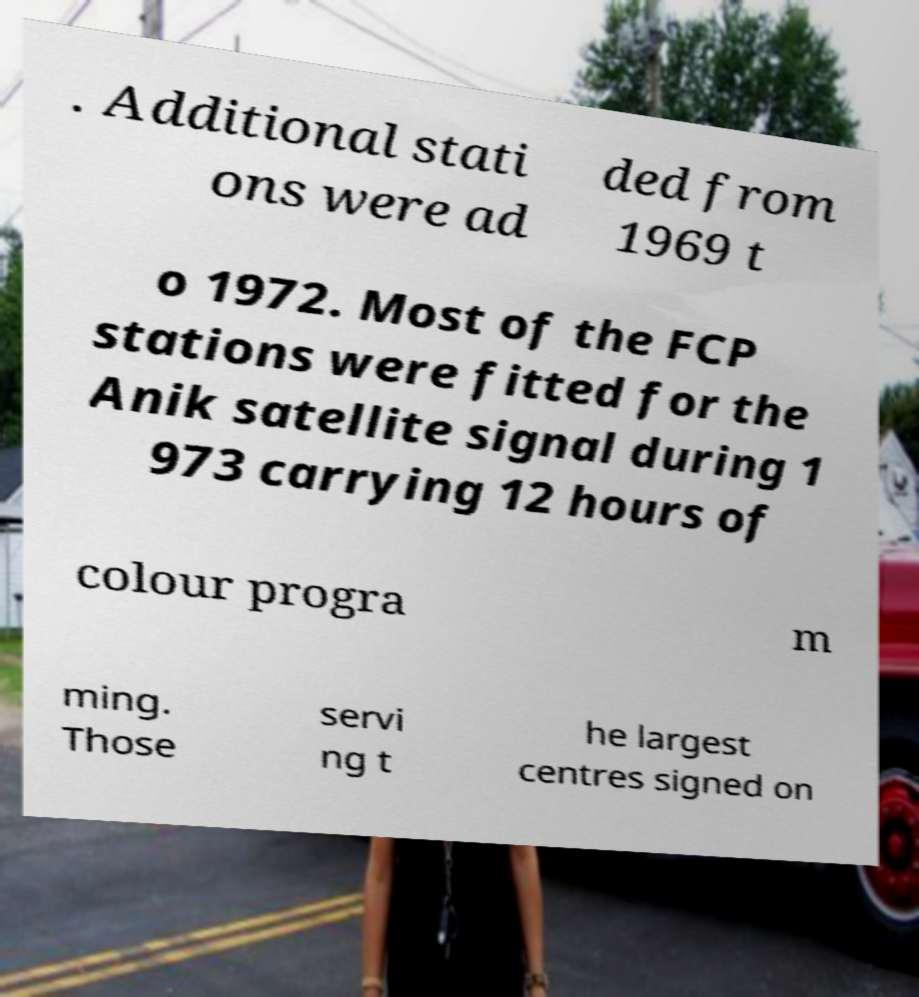What messages or text are displayed in this image? I need them in a readable, typed format. . Additional stati ons were ad ded from 1969 t o 1972. Most of the FCP stations were fitted for the Anik satellite signal during 1 973 carrying 12 hours of colour progra m ming. Those servi ng t he largest centres signed on 